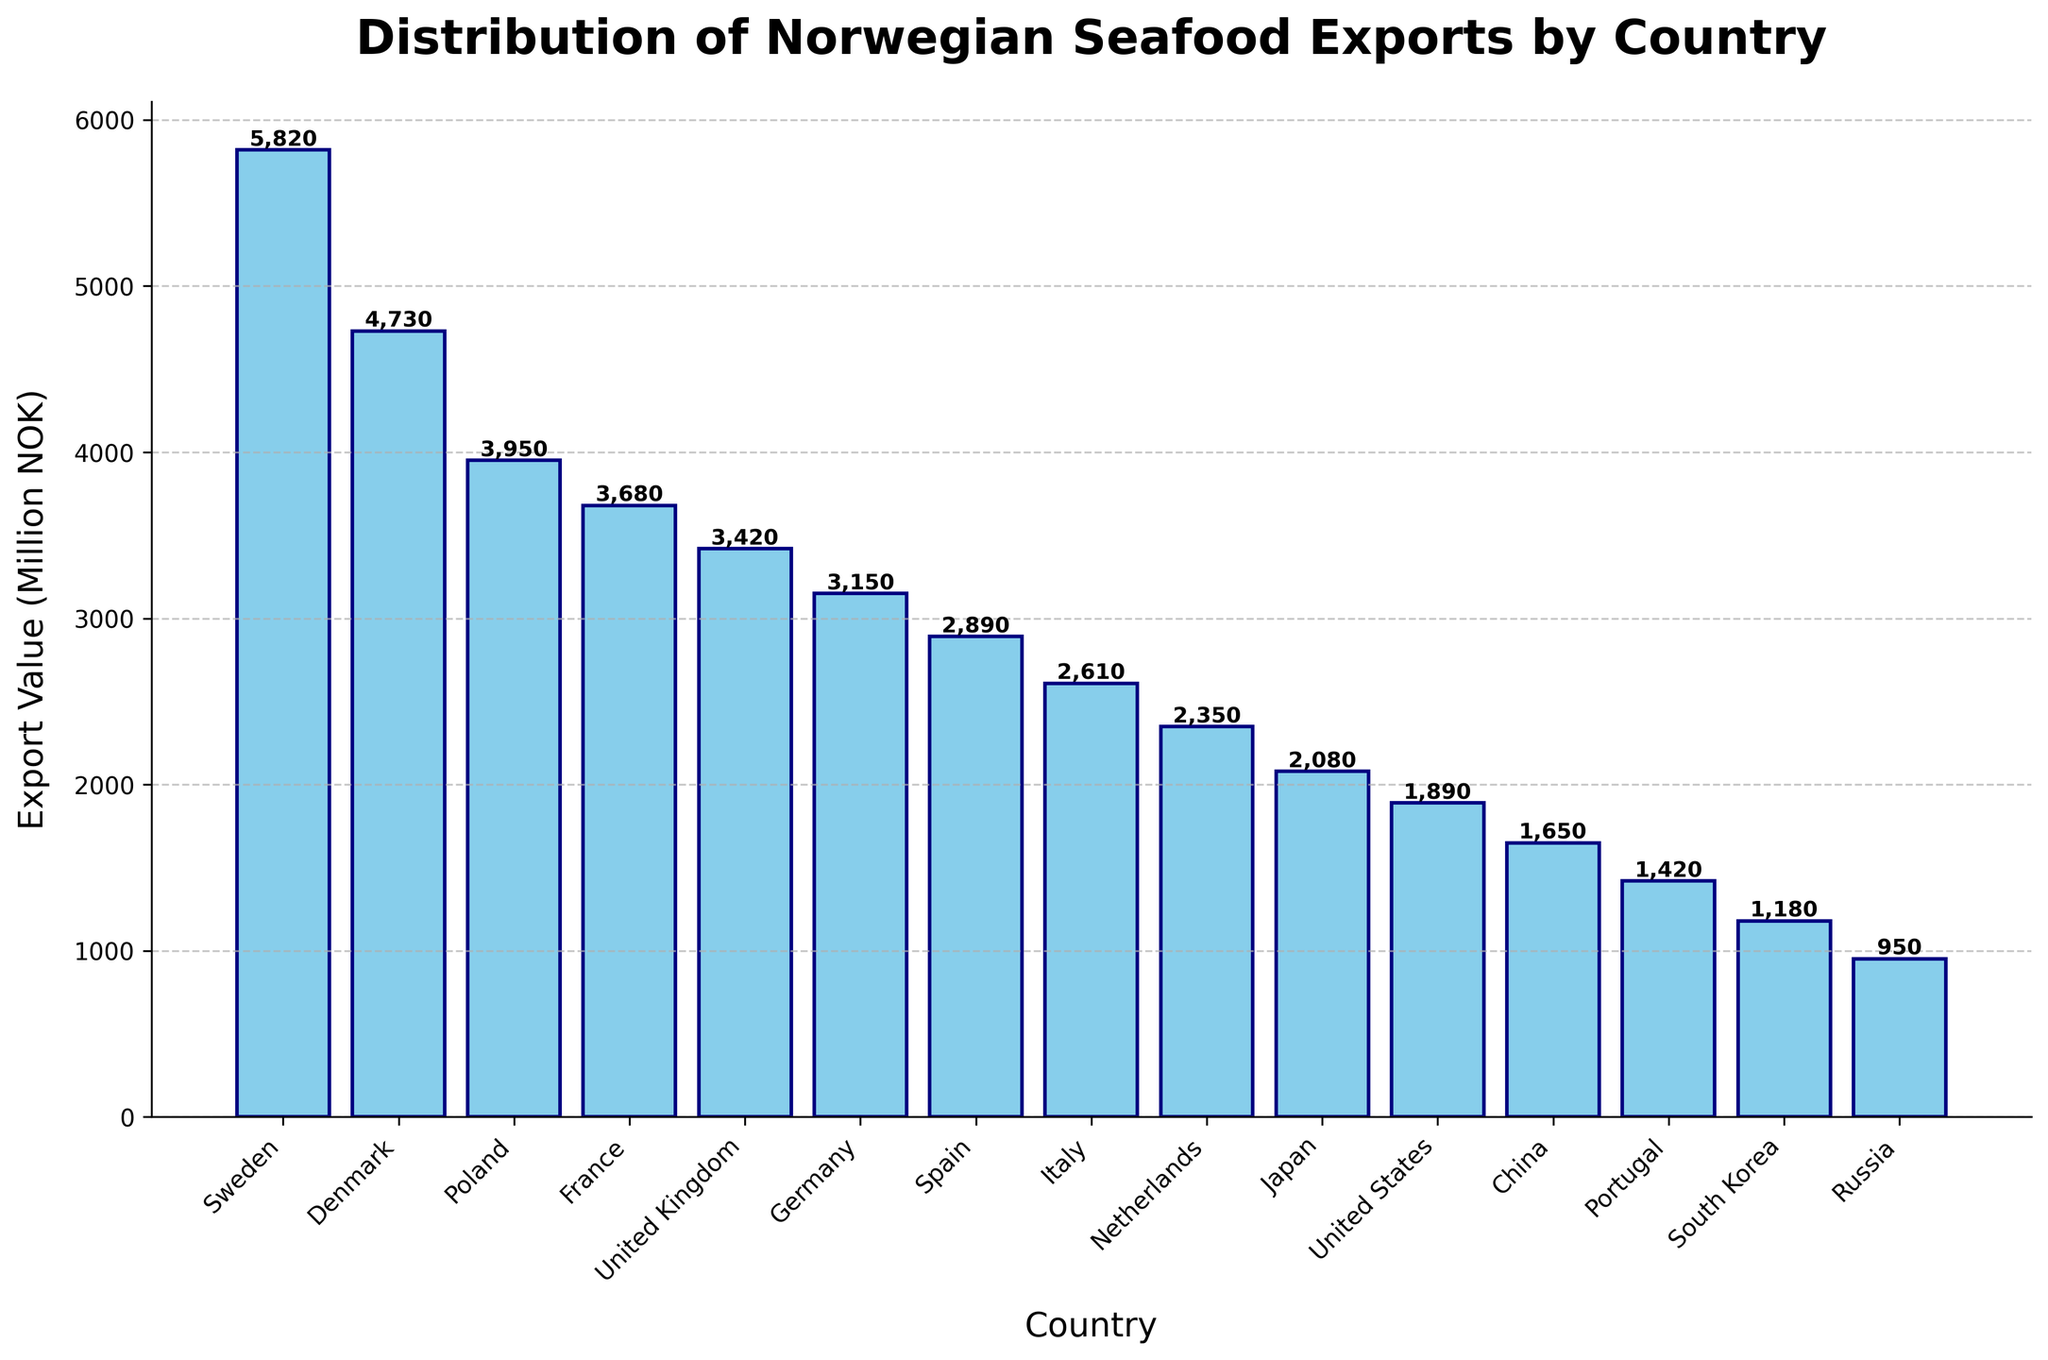Which country has the highest export value? The bar chart shows a variety of countries along the x-axis, with corresponding export values in millions of NOK along the y-axis. The bar representing Sweden is the tallest, indicating it has the highest export value.
Answer: Sweden Which country has the lowest export value? The bar chart shows several countries with varying export values. The bar representing Russia is the shortest, indicating it has the lowest export value.
Answer: Russia How much higher is the export value to Sweden compared to Denmark? The export value for Sweden is 5820 million NOK, and for Denmark, it is 4730 million NOK. The difference is calculated as 5820 - 4730 = 1090 million NOK.
Answer: 1090 million NOK What is the combined export value of top three countries? The top three countries with the highest export values are Sweden (5820 million NOK), Denmark (4730 million NOK), and Poland (3950 million NOK). The combined value is 5820 + 4730 + 3950 = 14500 million NOK.
Answer: 14500 million NOK What is the average export value among all listed countries? There are 15 countries listed. Sum the export values: 5820 + 4730 + 3950 + 3680 + 3420 + 3150 + 2890 + 2610 + 2350 + 2080 + 1890 + 1650 + 1420 + 1180 + 950 = 41570 million NOK. The average is 41570 / 15 ≈ 2771.33 million NOK.
Answer: 2771.33 million NOK Which countries have an export value between 2000 and 4000 million NOK? Looking at the bars within the 2000 to 4000 range on the y-axis, the countries are Poland (3950), France (3680), United Kingdom (3420), Germany (3150), Spain (2890), Italy (2610), and Netherlands (2350).
Answer: Poland, France, United Kingdom, Germany, Spain, Italy, Netherlands How does the export value to Japan compare to that of Italy? The export value to Japan is 2080 million NOK, while for Italy it is 2610 million NOK. Japan's export value is lower than Italy's.
Answer: Japan's export value is lower What is the total export value of all countries in Asia listed? Asian countries listed are Japan (2080 million NOK), China (1650 million NOK), and South Korea (1180 million NOK). The total export value is 2080 + 1650 + 1180 = 4910 million NOK.
Answer: 4910 million NOK Which country in the top five has the smallest export value and what is its value? The top five countries are Sweden, Denmark, Poland, France, and the United Kingdom. The United Kingdom has the smallest export value among them with 3420 million NOK.
Answer: United Kingdom, 3420 million NOK 